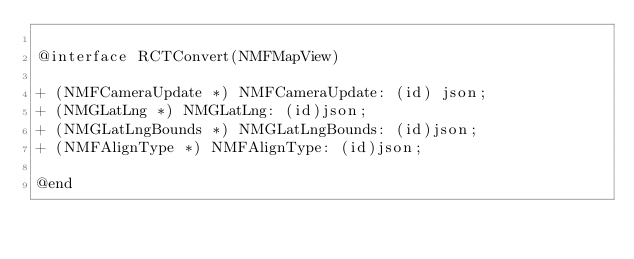Convert code to text. <code><loc_0><loc_0><loc_500><loc_500><_C_>
@interface RCTConvert(NMFMapView)

+ (NMFCameraUpdate *) NMFCameraUpdate: (id) json;
+ (NMGLatLng *) NMGLatLng: (id)json;
+ (NMGLatLngBounds *) NMGLatLngBounds: (id)json;
+ (NMFAlignType *) NMFAlignType: (id)json;

@end
</code> 